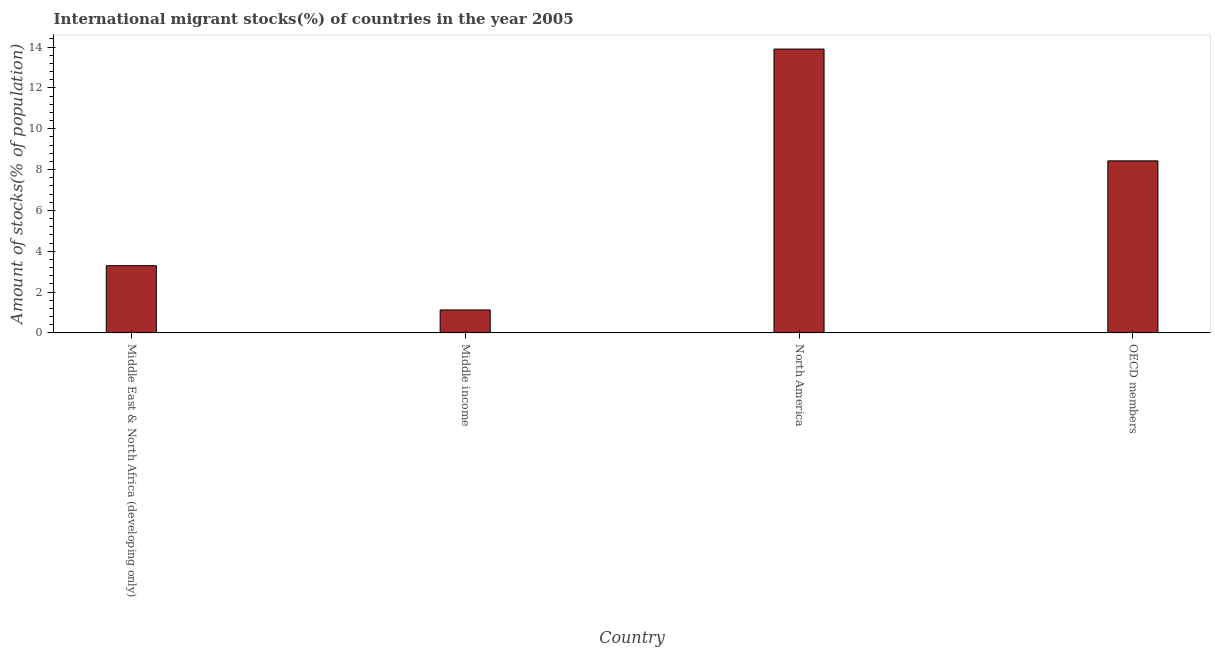Does the graph contain any zero values?
Offer a terse response. No. Does the graph contain grids?
Ensure brevity in your answer.  No. What is the title of the graph?
Your answer should be very brief. International migrant stocks(%) of countries in the year 2005. What is the label or title of the X-axis?
Keep it short and to the point. Country. What is the label or title of the Y-axis?
Make the answer very short. Amount of stocks(% of population). What is the number of international migrant stocks in Middle East & North Africa (developing only)?
Ensure brevity in your answer.  3.29. Across all countries, what is the maximum number of international migrant stocks?
Make the answer very short. 13.9. Across all countries, what is the minimum number of international migrant stocks?
Offer a very short reply. 1.13. What is the sum of the number of international migrant stocks?
Your answer should be very brief. 26.75. What is the difference between the number of international migrant stocks in Middle income and North America?
Keep it short and to the point. -12.78. What is the average number of international migrant stocks per country?
Your answer should be compact. 6.69. What is the median number of international migrant stocks?
Ensure brevity in your answer.  5.86. In how many countries, is the number of international migrant stocks greater than 3.6 %?
Keep it short and to the point. 2. What is the ratio of the number of international migrant stocks in Middle East & North Africa (developing only) to that in North America?
Make the answer very short. 0.24. Is the number of international migrant stocks in Middle East & North Africa (developing only) less than that in OECD members?
Make the answer very short. Yes. Is the difference between the number of international migrant stocks in Middle East & North Africa (developing only) and OECD members greater than the difference between any two countries?
Keep it short and to the point. No. What is the difference between the highest and the second highest number of international migrant stocks?
Offer a very short reply. 5.48. Is the sum of the number of international migrant stocks in North America and OECD members greater than the maximum number of international migrant stocks across all countries?
Make the answer very short. Yes. What is the difference between the highest and the lowest number of international migrant stocks?
Your answer should be very brief. 12.78. How many bars are there?
Your answer should be compact. 4. What is the Amount of stocks(% of population) of Middle East & North Africa (developing only)?
Make the answer very short. 3.29. What is the Amount of stocks(% of population) of Middle income?
Offer a very short reply. 1.13. What is the Amount of stocks(% of population) in North America?
Keep it short and to the point. 13.9. What is the Amount of stocks(% of population) in OECD members?
Keep it short and to the point. 8.43. What is the difference between the Amount of stocks(% of population) in Middle East & North Africa (developing only) and Middle income?
Your answer should be very brief. 2.17. What is the difference between the Amount of stocks(% of population) in Middle East & North Africa (developing only) and North America?
Keep it short and to the point. -10.61. What is the difference between the Amount of stocks(% of population) in Middle East & North Africa (developing only) and OECD members?
Provide a succinct answer. -5.13. What is the difference between the Amount of stocks(% of population) in Middle income and North America?
Provide a succinct answer. -12.78. What is the difference between the Amount of stocks(% of population) in Middle income and OECD members?
Your answer should be very brief. -7.3. What is the difference between the Amount of stocks(% of population) in North America and OECD members?
Provide a short and direct response. 5.48. What is the ratio of the Amount of stocks(% of population) in Middle East & North Africa (developing only) to that in Middle income?
Keep it short and to the point. 2.92. What is the ratio of the Amount of stocks(% of population) in Middle East & North Africa (developing only) to that in North America?
Make the answer very short. 0.24. What is the ratio of the Amount of stocks(% of population) in Middle East & North Africa (developing only) to that in OECD members?
Keep it short and to the point. 0.39. What is the ratio of the Amount of stocks(% of population) in Middle income to that in North America?
Your answer should be very brief. 0.08. What is the ratio of the Amount of stocks(% of population) in Middle income to that in OECD members?
Offer a very short reply. 0.13. What is the ratio of the Amount of stocks(% of population) in North America to that in OECD members?
Keep it short and to the point. 1.65. 